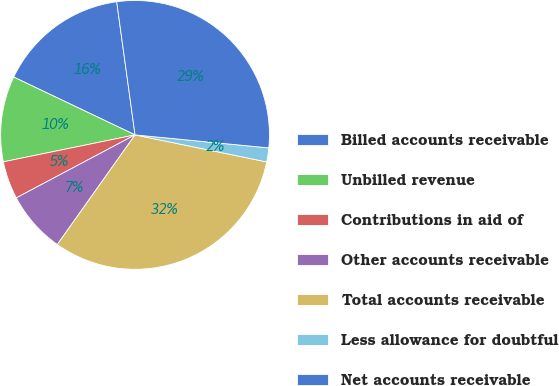Convert chart. <chart><loc_0><loc_0><loc_500><loc_500><pie_chart><fcel>Billed accounts receivable<fcel>Unbilled revenue<fcel>Contributions in aid of<fcel>Other accounts receivable<fcel>Total accounts receivable<fcel>Less allowance for doubtful<fcel>Net accounts receivable<nl><fcel>15.74%<fcel>10.29%<fcel>4.55%<fcel>7.42%<fcel>31.59%<fcel>1.68%<fcel>28.72%<nl></chart> 